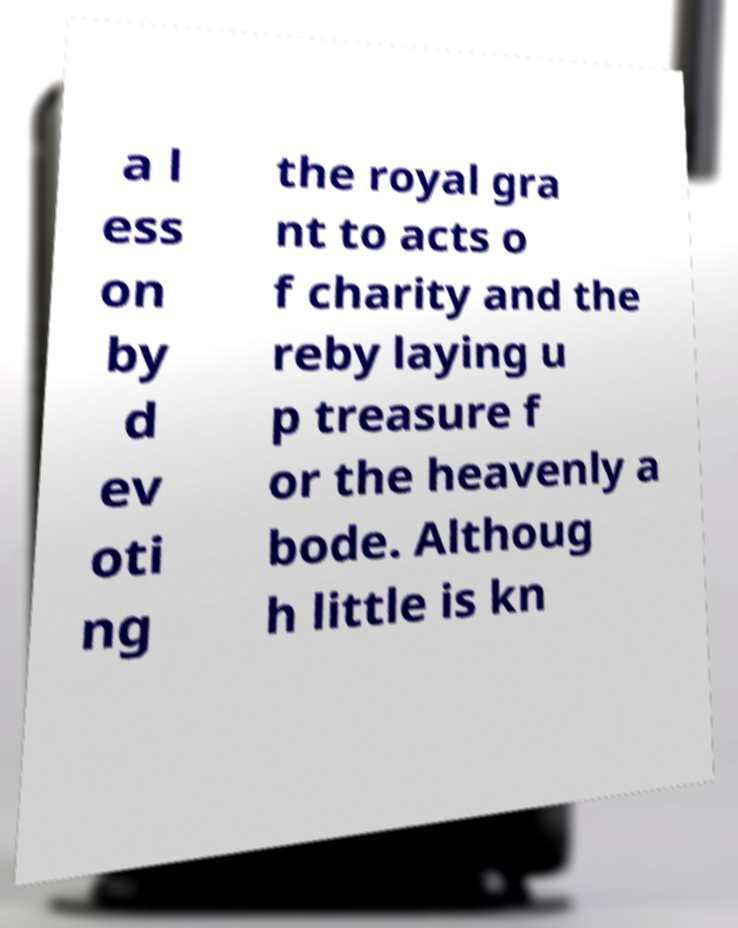For documentation purposes, I need the text within this image transcribed. Could you provide that? a l ess on by d ev oti ng the royal gra nt to acts o f charity and the reby laying u p treasure f or the heavenly a bode. Althoug h little is kn 